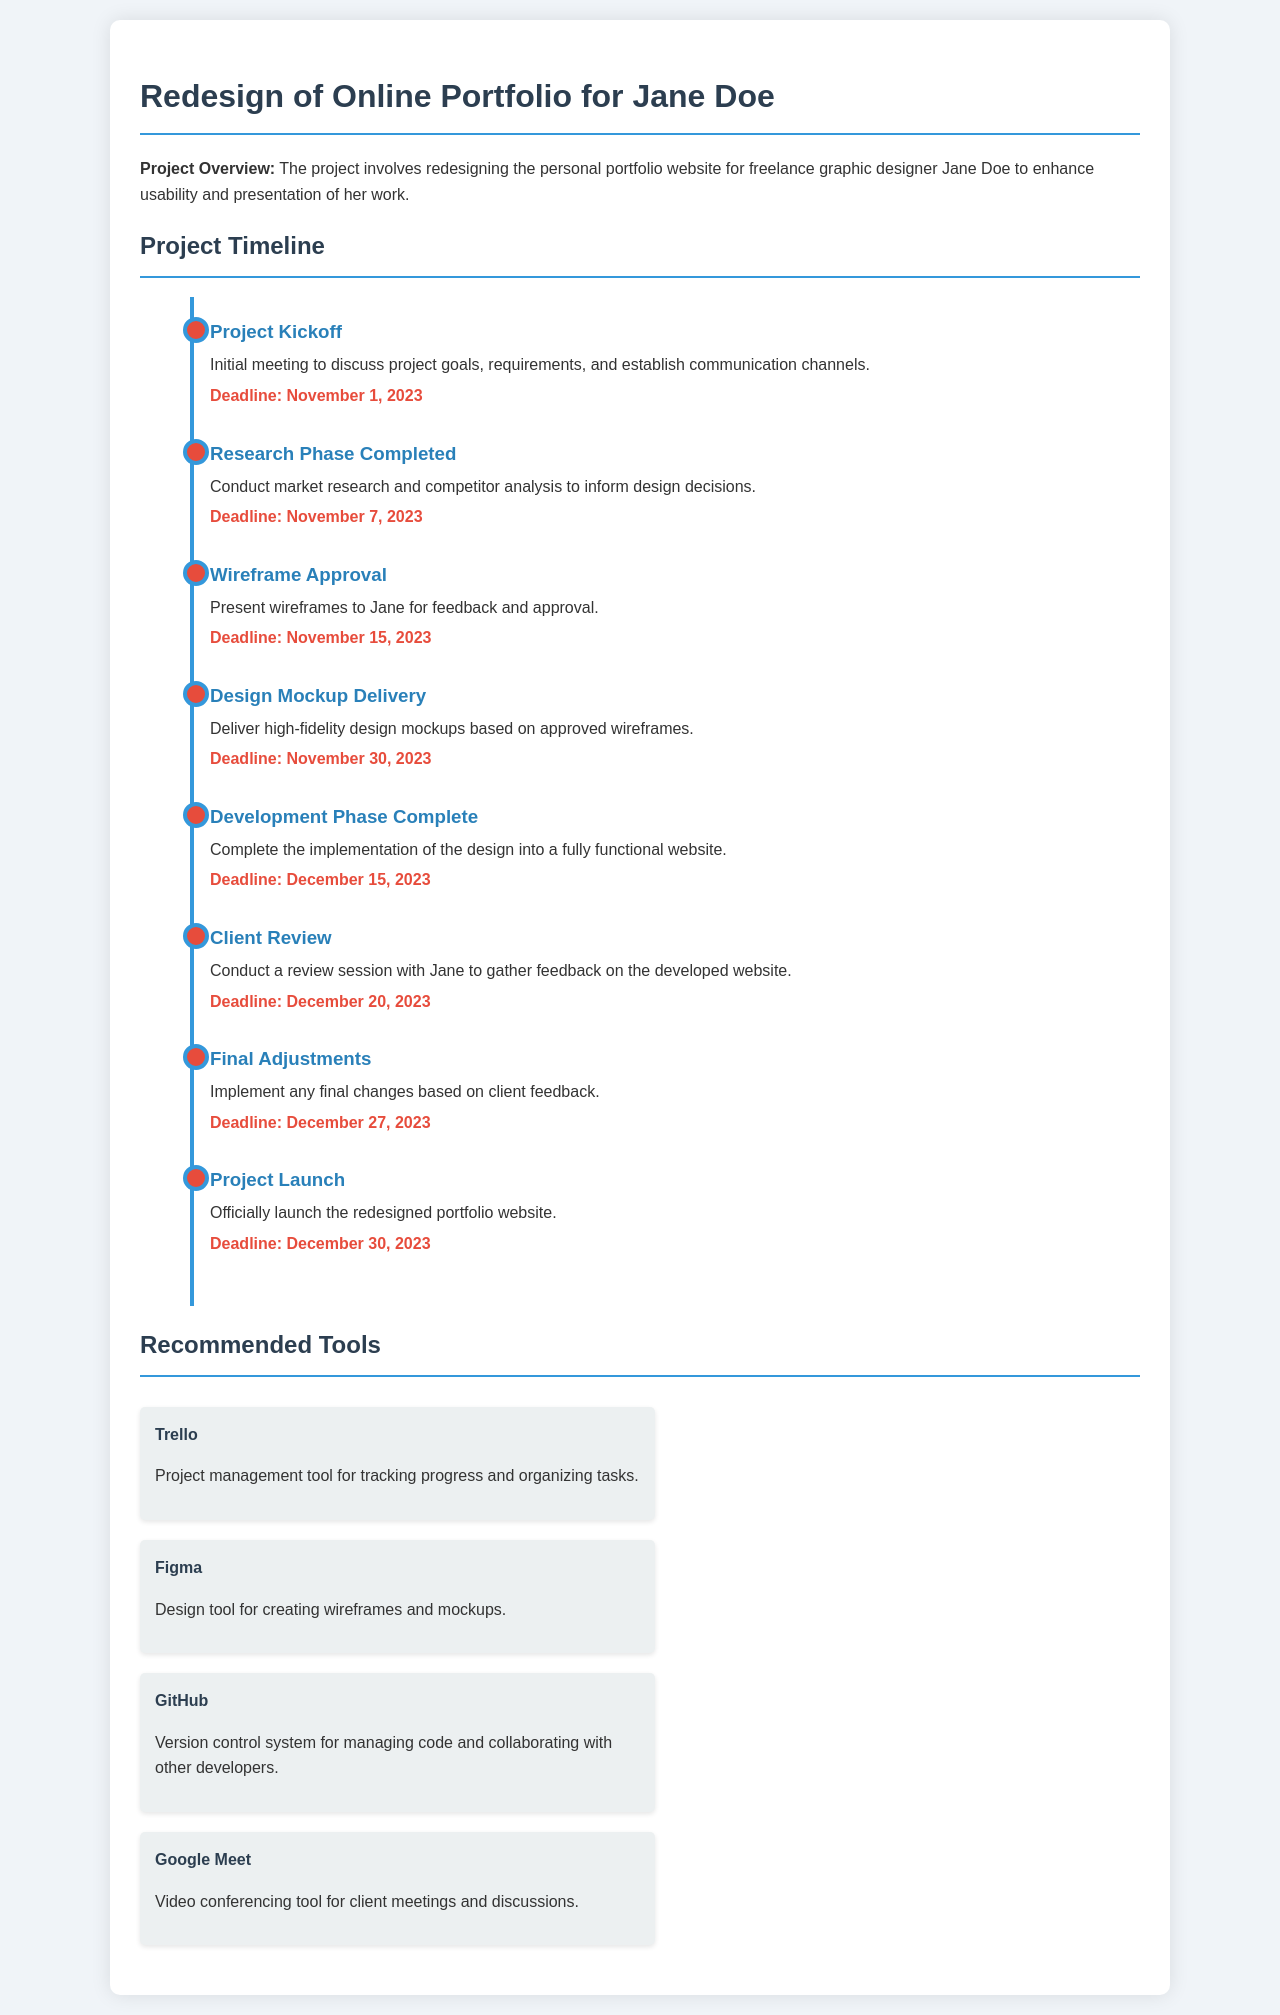What is the project title? The project title is mentioned at the beginning of the document, which is "Redesign of Online Portfolio for Jane Doe."
Answer: Redesign of Online Portfolio for Jane Doe What is the deadline for the Project Kickoff? The deadline for the Project Kickoff is specifically stated in the document.
Answer: November 1, 2023 How many milestones are listed in the timeline? The number of milestones can be counted directly in the timeline section of the document.
Answer: Eight What is the deadline for the Design Mockup Delivery? The deadline for the Design Mockup Delivery is provided in the timeline section of the document.
Answer: November 30, 2023 Which tool is recommended for video conferencing? The document specifies the recommended tools, including the one for video conferencing.
Answer: Google Meet What phase comes after the Wireframe Approval? The order of milestones indicates what comes next after the Wireframe Approval.
Answer: Design Mockup Delivery When is the Project Launch scheduled? The document clearly lists the date for the Project Launch milestone.
Answer: December 30, 2023 What is the main purpose of the project? The document provides a brief overview outlining the purpose of the project.
Answer: Enhance usability and presentation of her work 